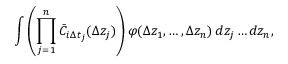Convert formula to latex. <formula><loc_0><loc_0><loc_500><loc_500>\int \left ( \prod _ { j = 1 } ^ { n } \bar { C } _ { i \Delta t _ { j } } ( \Delta z _ { j } ) \right ) \varphi ( \Delta z _ { 1 } , \dots , \Delta z _ { n } ) \, { d { z _ { j } } \dots d { z _ { n } } } ,</formula> 